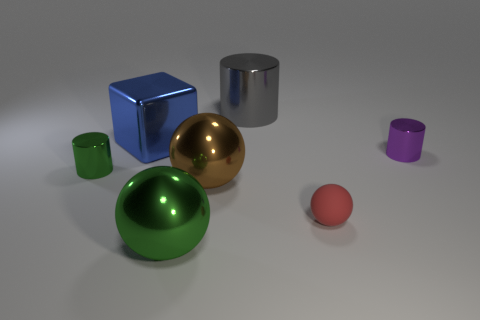The green thing in front of the small metallic cylinder that is left of the big gray cylinder is made of what material?
Make the answer very short. Metal. Is the number of purple metal objects greater than the number of cylinders?
Your response must be concise. No. Is the shiny cube the same color as the matte object?
Offer a very short reply. No. There is a brown object that is the same size as the gray cylinder; what is it made of?
Keep it short and to the point. Metal. Do the tiny green thing and the small sphere have the same material?
Provide a succinct answer. No. How many large cylinders have the same material as the blue cube?
Give a very brief answer. 1. How many things are either things behind the blue metallic thing or metallic objects behind the tiny red matte sphere?
Provide a succinct answer. 5. Are there more spheres in front of the small red rubber object than large cylinders that are to the right of the large gray metallic cylinder?
Ensure brevity in your answer.  Yes. What is the color of the big sphere in front of the tiny red matte thing?
Ensure brevity in your answer.  Green. Are there any big gray metal things that have the same shape as the tiny green thing?
Provide a short and direct response. Yes. 